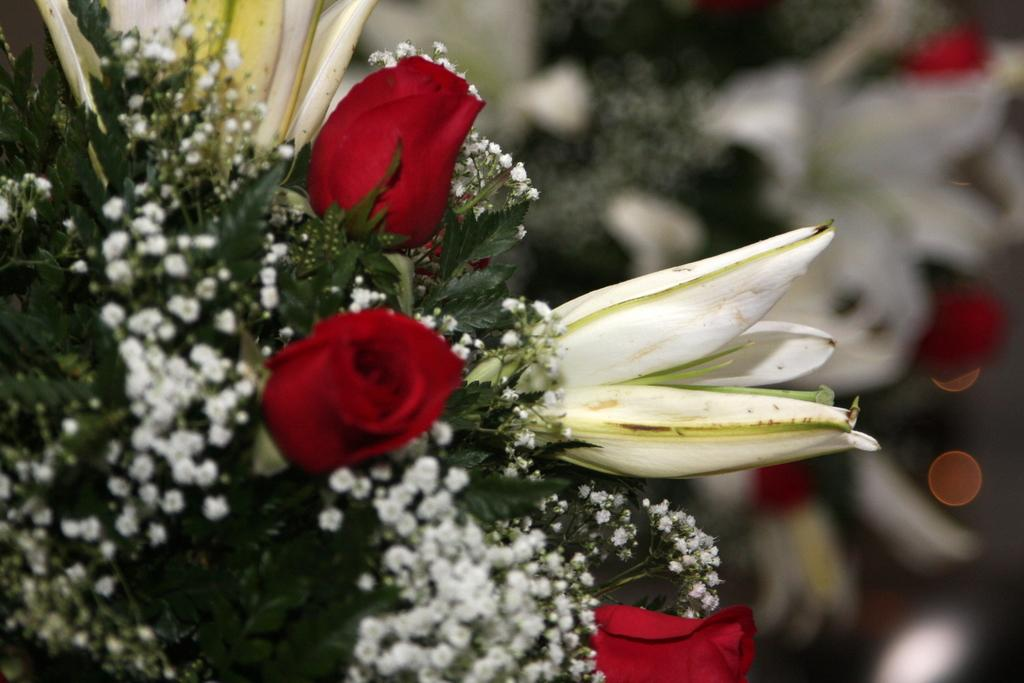What is the main subject of the image? The main subject of the image is a book key. What decorative elements are present on the book key? Flowers and leaves are visible on the left side of the book key. Is there any indication of a flower on the right side of the book key? There might be a flower on the right side of the book key. What type of machine is being used for learning in the image? There is no machine or learning activity depicted in the image; it features a book key with decorative elements. 